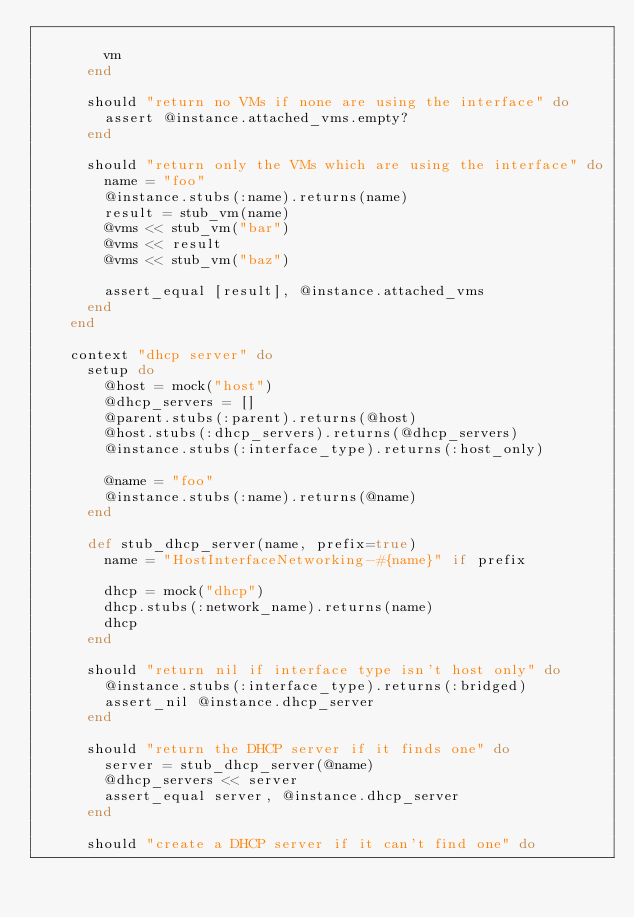Convert code to text. <code><loc_0><loc_0><loc_500><loc_500><_Ruby_>
        vm
      end

      should "return no VMs if none are using the interface" do
        assert @instance.attached_vms.empty?
      end

      should "return only the VMs which are using the interface" do
        name = "foo"
        @instance.stubs(:name).returns(name)
        result = stub_vm(name)
        @vms << stub_vm("bar")
        @vms << result
        @vms << stub_vm("baz")

        assert_equal [result], @instance.attached_vms
      end
    end

    context "dhcp server" do
      setup do
        @host = mock("host")
        @dhcp_servers = []
        @parent.stubs(:parent).returns(@host)
        @host.stubs(:dhcp_servers).returns(@dhcp_servers)
        @instance.stubs(:interface_type).returns(:host_only)

        @name = "foo"
        @instance.stubs(:name).returns(@name)
      end

      def stub_dhcp_server(name, prefix=true)
        name = "HostInterfaceNetworking-#{name}" if prefix

        dhcp = mock("dhcp")
        dhcp.stubs(:network_name).returns(name)
        dhcp
      end

      should "return nil if interface type isn't host only" do
        @instance.stubs(:interface_type).returns(:bridged)
        assert_nil @instance.dhcp_server
      end

      should "return the DHCP server if it finds one" do
        server = stub_dhcp_server(@name)
        @dhcp_servers << server
        assert_equal server, @instance.dhcp_server
      end

      should "create a DHCP server if it can't find one" do</code> 